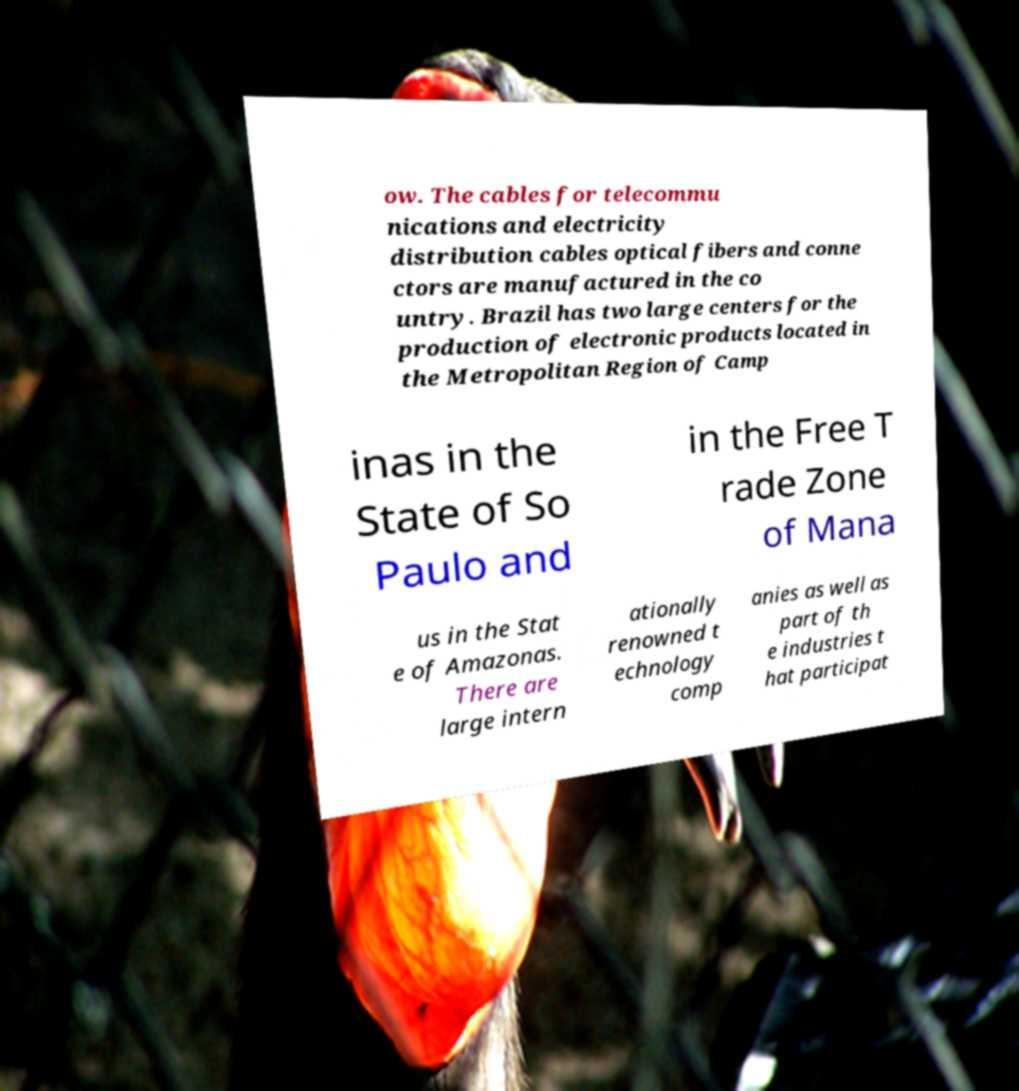Could you assist in decoding the text presented in this image and type it out clearly? ow. The cables for telecommu nications and electricity distribution cables optical fibers and conne ctors are manufactured in the co untry. Brazil has two large centers for the production of electronic products located in the Metropolitan Region of Camp inas in the State of So Paulo and in the Free T rade Zone of Mana us in the Stat e of Amazonas. There are large intern ationally renowned t echnology comp anies as well as part of th e industries t hat participat 